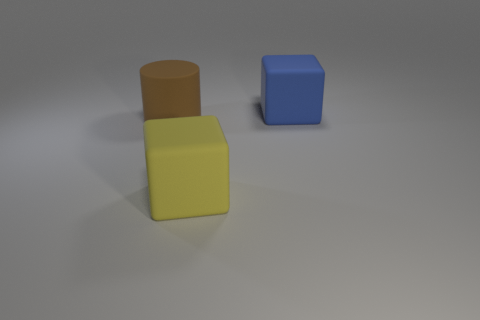Does the big block that is behind the brown matte thing have the same material as the cube in front of the brown matte cylinder?
Keep it short and to the point. Yes. There is a rubber thing in front of the brown matte cylinder; how big is it?
Ensure brevity in your answer.  Large. There is a big yellow object that is the same shape as the blue thing; what is its material?
Offer a very short reply. Rubber. There is a matte object behind the cylinder; what shape is it?
Ensure brevity in your answer.  Cube. How many large brown things have the same shape as the blue thing?
Keep it short and to the point. 0. Is the number of big blue objects that are on the left side of the large blue rubber block the same as the number of blue matte objects on the left side of the brown matte cylinder?
Ensure brevity in your answer.  Yes. Are there any large red cubes that have the same material as the brown object?
Make the answer very short. No. How many red things are large rubber blocks or matte cylinders?
Ensure brevity in your answer.  0. Is the number of yellow cubes in front of the big brown thing greater than the number of large green things?
Offer a very short reply. Yes. What size is the yellow rubber thing?
Provide a succinct answer. Large. 